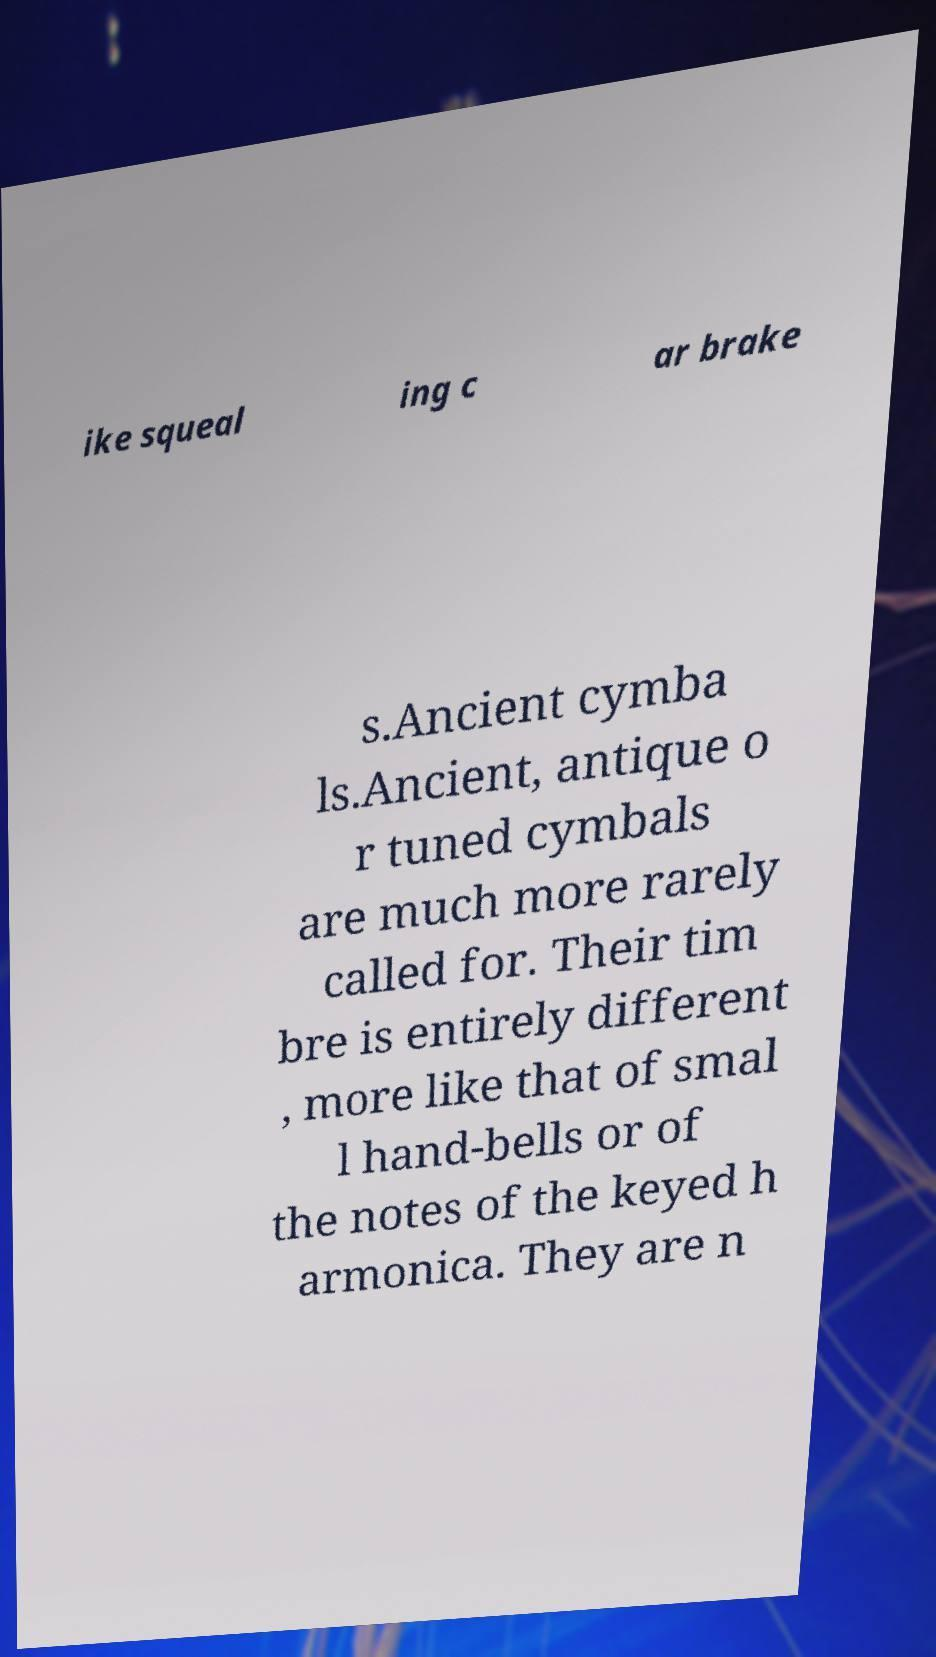What messages or text are displayed in this image? I need them in a readable, typed format. ike squeal ing c ar brake s.Ancient cymba ls.Ancient, antique o r tuned cymbals are much more rarely called for. Their tim bre is entirely different , more like that of smal l hand-bells or of the notes of the keyed h armonica. They are n 